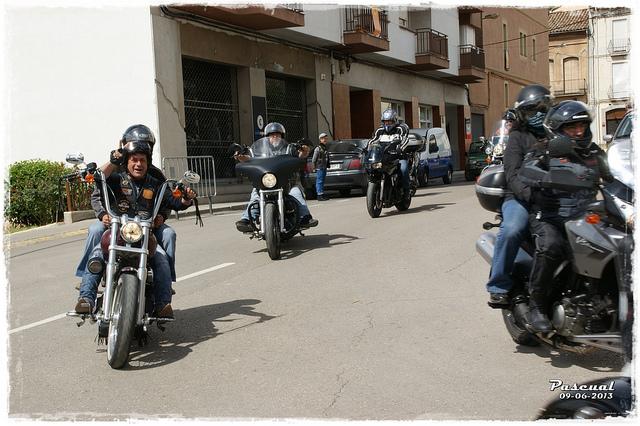Are the people pushing their motorcycles?
Keep it brief. No. What type of pants are the bikers wearing?
Concise answer only. Jeans. How many people are on bikes?
Concise answer only. 6. 